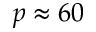<formula> <loc_0><loc_0><loc_500><loc_500>p \approx 6 0</formula> 